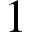<formula> <loc_0><loc_0><loc_500><loc_500>1</formula> 